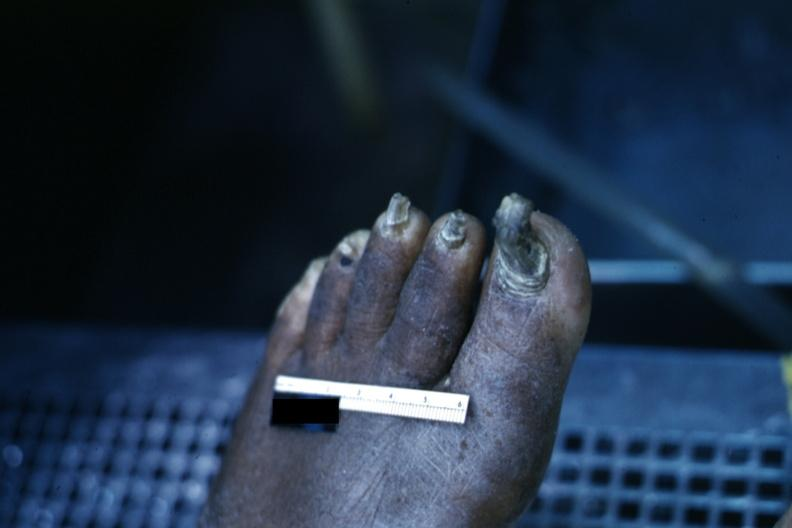s glomerulosa present?
Answer the question using a single word or phrase. No 